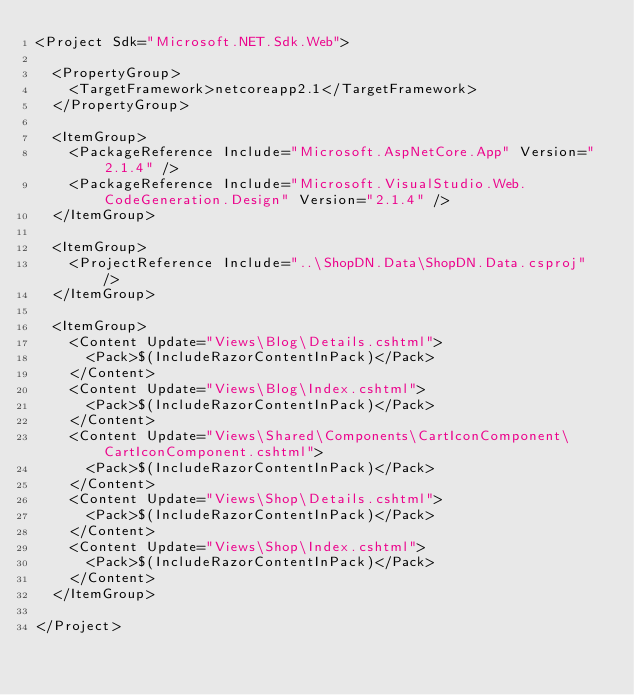Convert code to text. <code><loc_0><loc_0><loc_500><loc_500><_XML_><Project Sdk="Microsoft.NET.Sdk.Web">

  <PropertyGroup>
    <TargetFramework>netcoreapp2.1</TargetFramework>
  </PropertyGroup>

  <ItemGroup>
    <PackageReference Include="Microsoft.AspNetCore.App" Version="2.1.4" />
    <PackageReference Include="Microsoft.VisualStudio.Web.CodeGeneration.Design" Version="2.1.4" />
  </ItemGroup>

  <ItemGroup>
    <ProjectReference Include="..\ShopDN.Data\ShopDN.Data.csproj" />
  </ItemGroup>

  <ItemGroup>
    <Content Update="Views\Blog\Details.cshtml">
      <Pack>$(IncludeRazorContentInPack)</Pack>
    </Content>
    <Content Update="Views\Blog\Index.cshtml">
      <Pack>$(IncludeRazorContentInPack)</Pack>
    </Content>
    <Content Update="Views\Shared\Components\CartIconComponent\CartIconComponent.cshtml">
      <Pack>$(IncludeRazorContentInPack)</Pack>
    </Content>
    <Content Update="Views\Shop\Details.cshtml">
      <Pack>$(IncludeRazorContentInPack)</Pack>
    </Content>
    <Content Update="Views\Shop\Index.cshtml">
      <Pack>$(IncludeRazorContentInPack)</Pack>
    </Content>
  </ItemGroup>

</Project>
</code> 